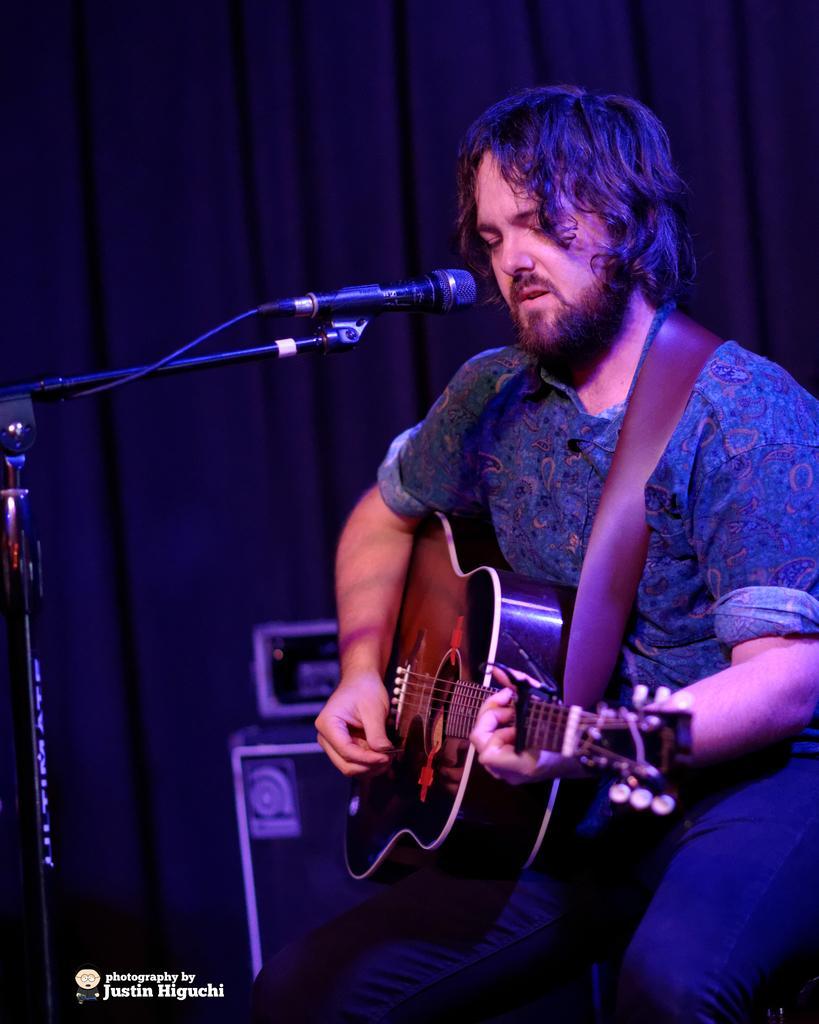Please provide a concise description of this image. In this image, we can see a man sitting and he is holding a guitar, he is singing in the black color microphone, in the background there is a curtain. 